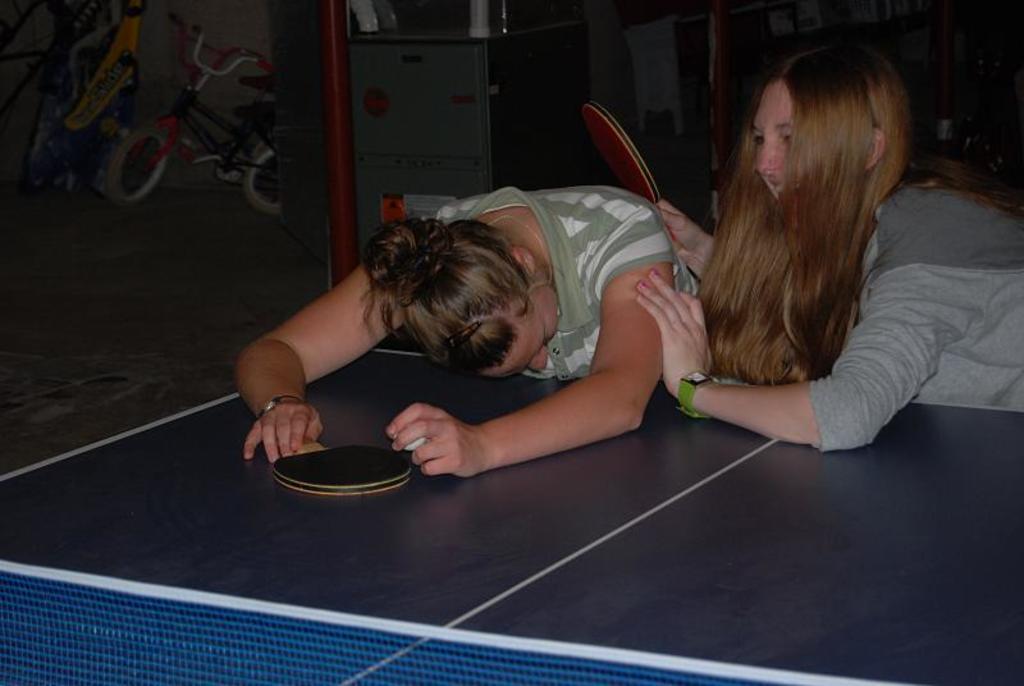How would you summarize this image in a sentence or two? There are two women's holding table tennis bats in their hands and laid on a table tennis table. 